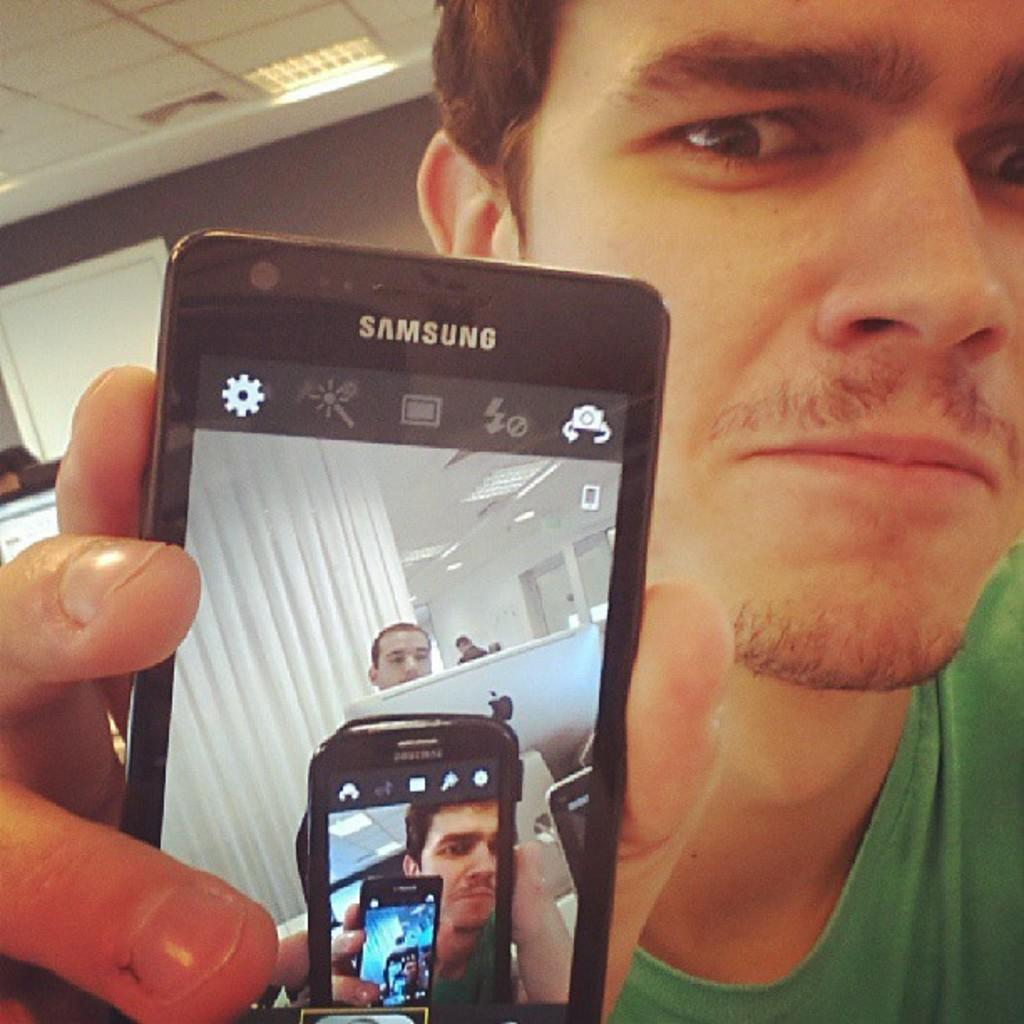<image>
Offer a succinct explanation of the picture presented. A man holding up a samsung phone with the camera app open. 